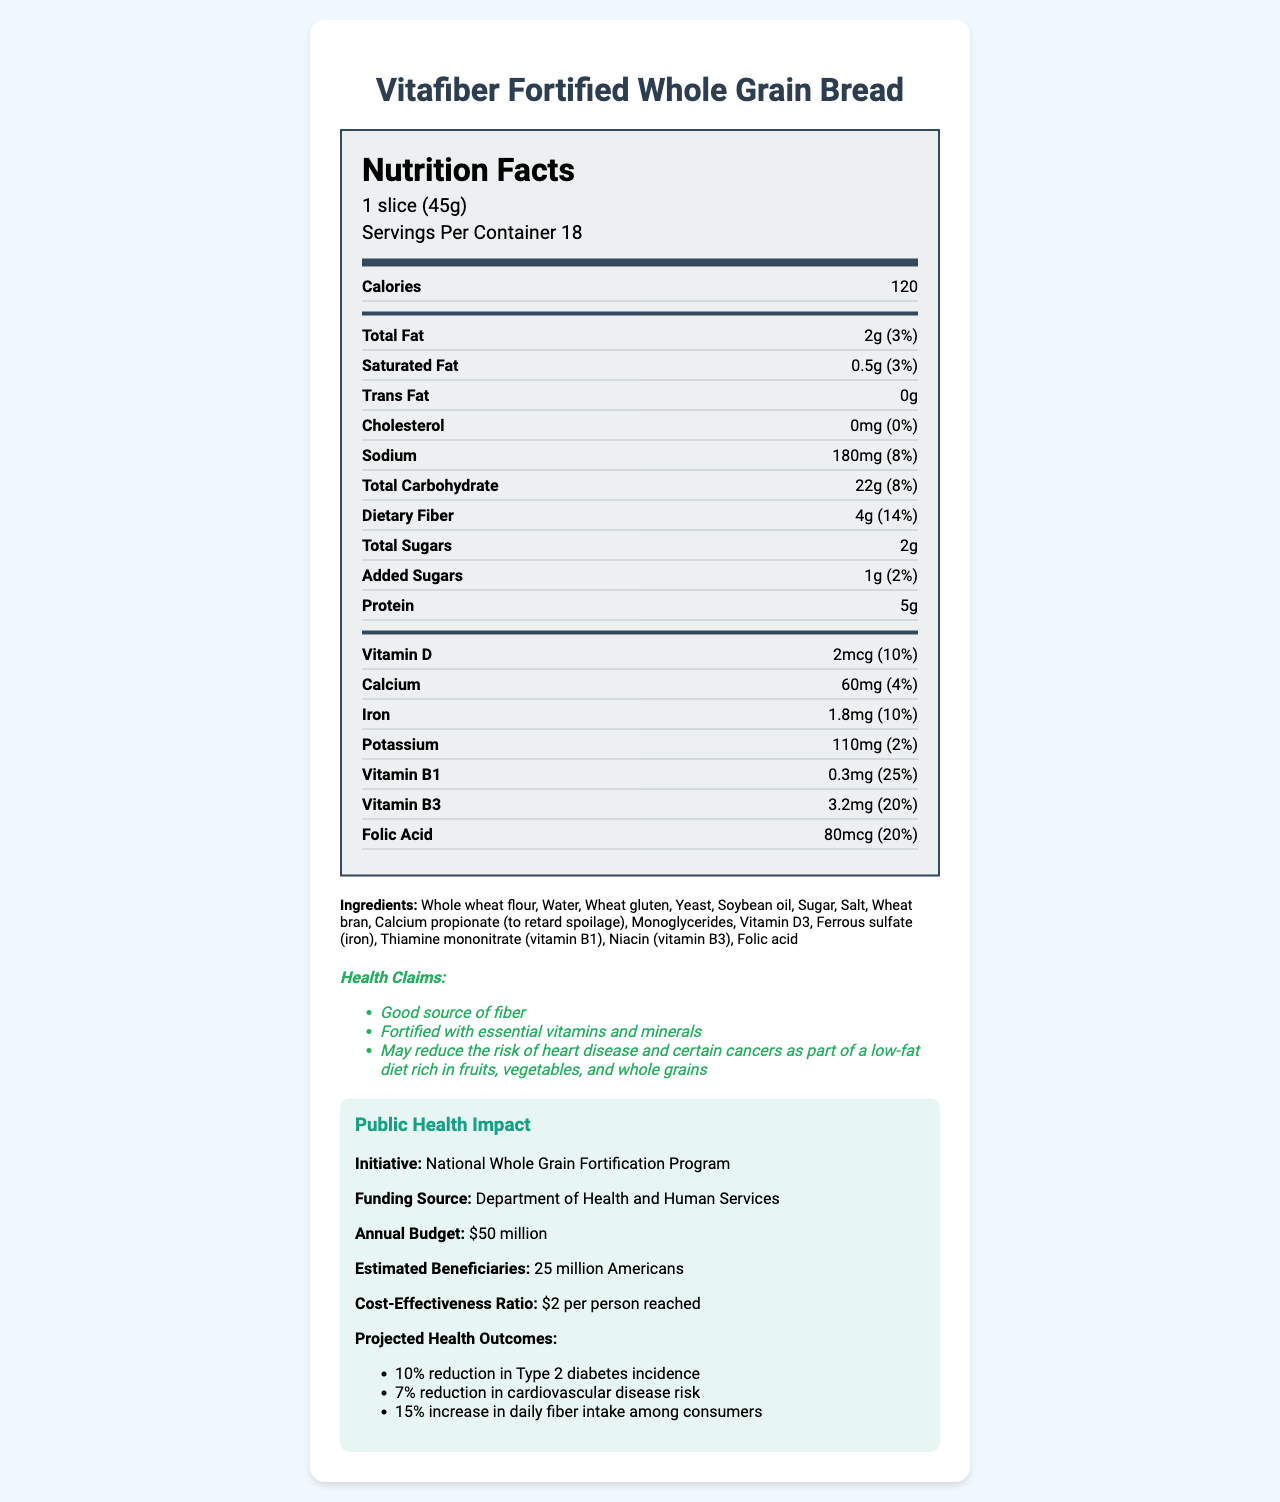what is the serving size? The serving size is indicated in the document under "Nutrition Facts" as "1 slice (45g)."
Answer: 1 slice (45g) how many servings are there per container? The document states "Servings Per Container 18" under the "Nutrition Facts" section.
Answer: 18 how many calories are there per serving? Under the "Nutrition Facts" section, it shows "Calories 120."
Answer: 120 calories what is the total amount of dietary fiber per serving? The amount of dietary fiber per serving is listed as "4g" under the "Total Carbohydrate" section in "Nutrition Facts."
Answer: 4g what percentage of the daily value of Vitamin B1 does one serving provide? The "Vitamin B1" section lists the percent daily value as "25%."
Answer: 25% what allergens are present in this product? The document includes an "allergen warning" stating "Contains: Wheat, Soy."
Answer: Wheat, Soy what is the annual budget for the funding source? Under the "Public Health Impact" section, the annual budget is listed as "$50 million."
Answer: $50 million list three ingredients found in this bread. The ingredients list includes these ingredients among others.
Answer: Whole wheat flour, Water, Wheat gluten which vitamin is present at a 10% daily value per serving? A. Vitamin D B. Calcium C. Iron D. Folic Acid Vitamin D has a percent daily value of 10%, compared to Calcium (4%), Iron (10%), and Folic Acid (20%).
Answer: A. Vitamin D how much sodium is there in one slice of bread? A. 180mg B. 150mg C. 200mg D. 110mg The sodium content per serving is listed as "180mg" in the "Nutrition Facts" section.
Answer: A. 180mg are there any trans fats in this product? The "Trans Fat" section has "0g" listed, indicating no trans fats.
Answer: No does this product contain cholesterol? The "Cholesterol" section lists "0mg," indicating there is no cholesterol in the product.
Answer: No summarize the main ideas of this document. The document offers a comprehensive view of the nutritional content of one slice of bread, highlights the ingredients and potential allergens, and discusses the benefits of the public health initiative funding the fortification of the bread.
Answer: The document is a Nutrition Facts Label for "Vitafiber Fortified Whole Grain Bread," detailing the nutritional content per serving, ingredients, allergens, health claims, and public health funding impact. what is the estimated number of beneficiaries of the health initiative? The "Public Health Impact" section states "estimated beneficiaries: 25 million Americans."
Answer: 25 million Americans can we determine the exact manufacturing process of the bread from this document? The document provides nutritional and ingredient details but does not describe the manufacturing process.
Answer: Not enough information 